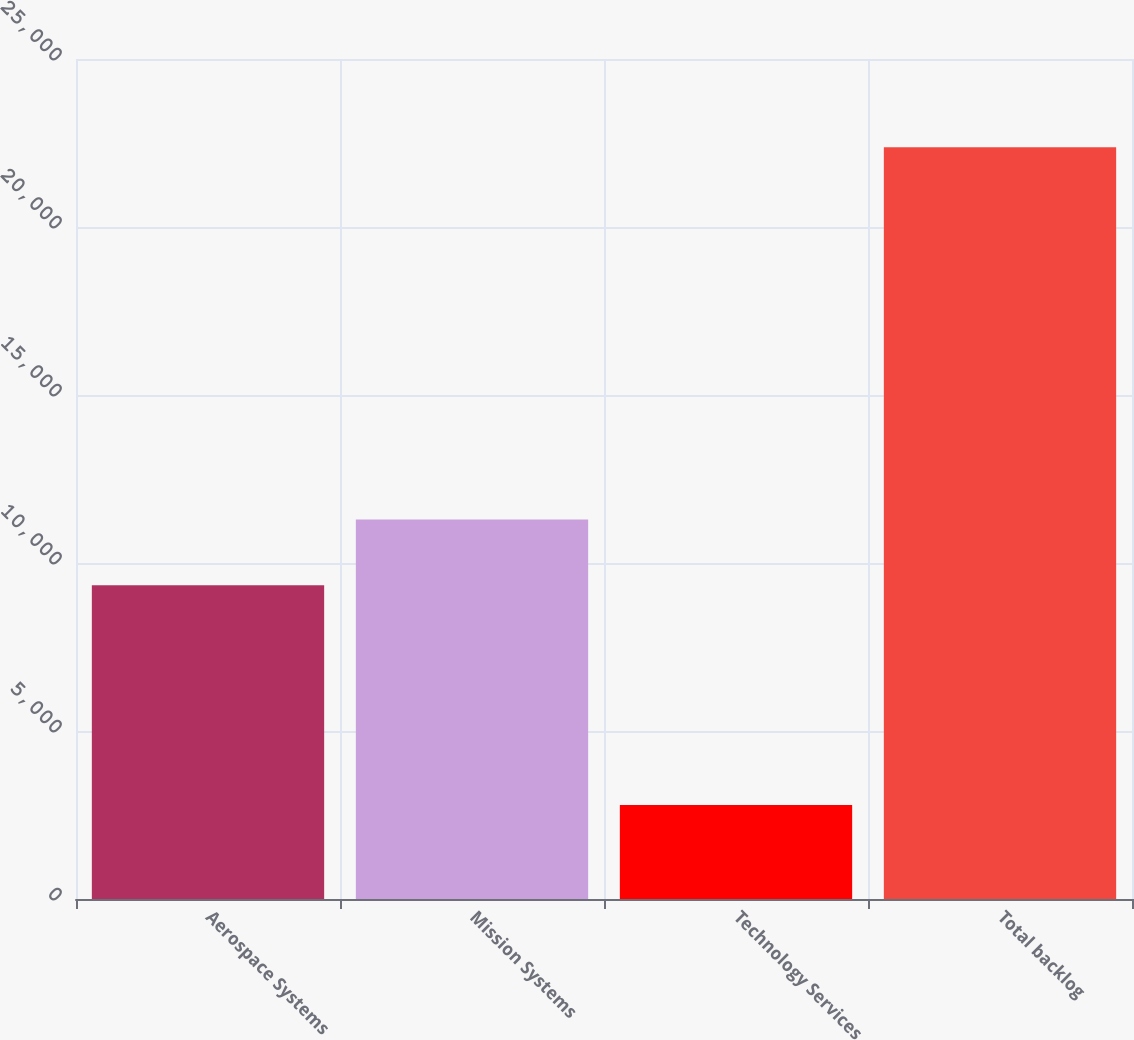Convert chart to OTSL. <chart><loc_0><loc_0><loc_500><loc_500><bar_chart><fcel>Aerospace Systems<fcel>Mission Systems<fcel>Technology Services<fcel>Total backlog<nl><fcel>9335<fcel>11292.6<fcel>2797<fcel>22373<nl></chart> 